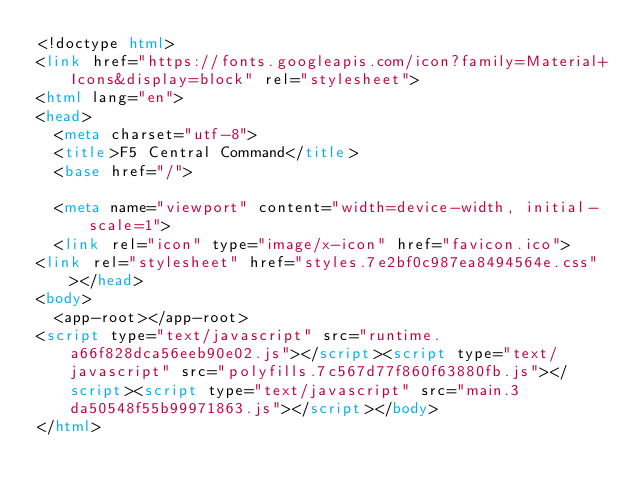Convert code to text. <code><loc_0><loc_0><loc_500><loc_500><_HTML_><!doctype html>
<link href="https://fonts.googleapis.com/icon?family=Material+Icons&display=block" rel="stylesheet">
<html lang="en">
<head>
  <meta charset="utf-8">
  <title>F5 Central Command</title>
  <base href="/">

  <meta name="viewport" content="width=device-width, initial-scale=1">
  <link rel="icon" type="image/x-icon" href="favicon.ico">
<link rel="stylesheet" href="styles.7e2bf0c987ea8494564e.css"></head>
<body>
  <app-root></app-root>
<script type="text/javascript" src="runtime.a66f828dca56eeb90e02.js"></script><script type="text/javascript" src="polyfills.7c567d77f860f63880fb.js"></script><script type="text/javascript" src="main.3da50548f55b99971863.js"></script></body>
</html>
</code> 